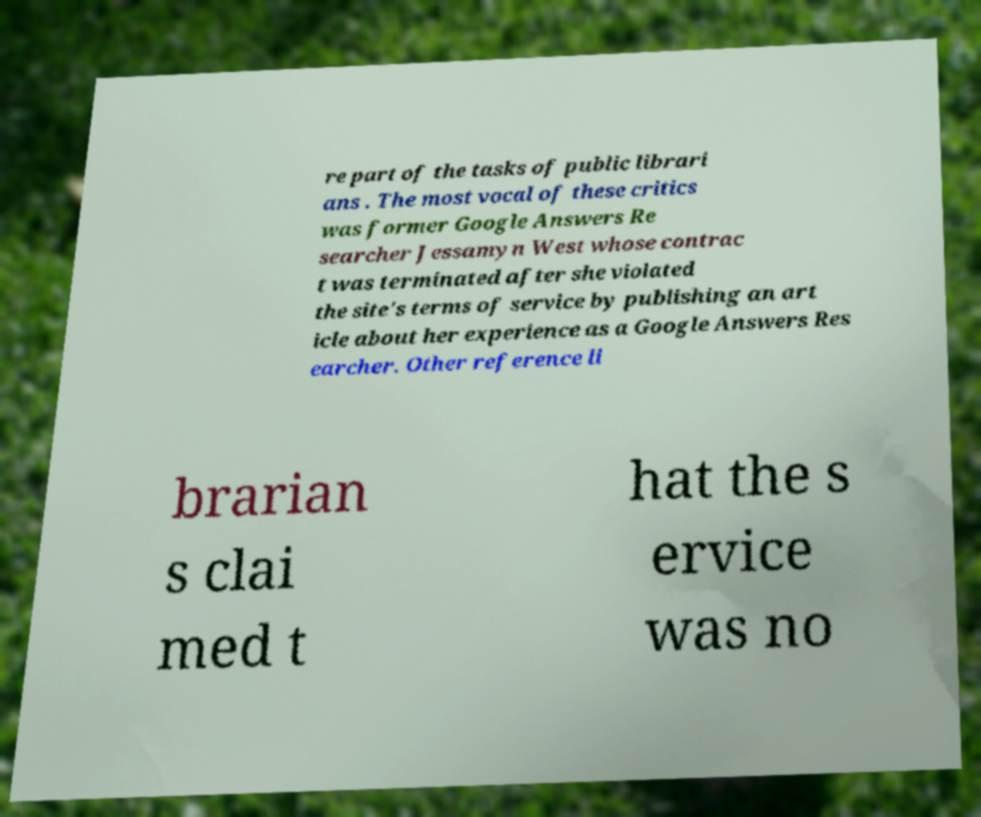Could you assist in decoding the text presented in this image and type it out clearly? re part of the tasks of public librari ans . The most vocal of these critics was former Google Answers Re searcher Jessamyn West whose contrac t was terminated after she violated the site's terms of service by publishing an art icle about her experience as a Google Answers Res earcher. Other reference li brarian s clai med t hat the s ervice was no 